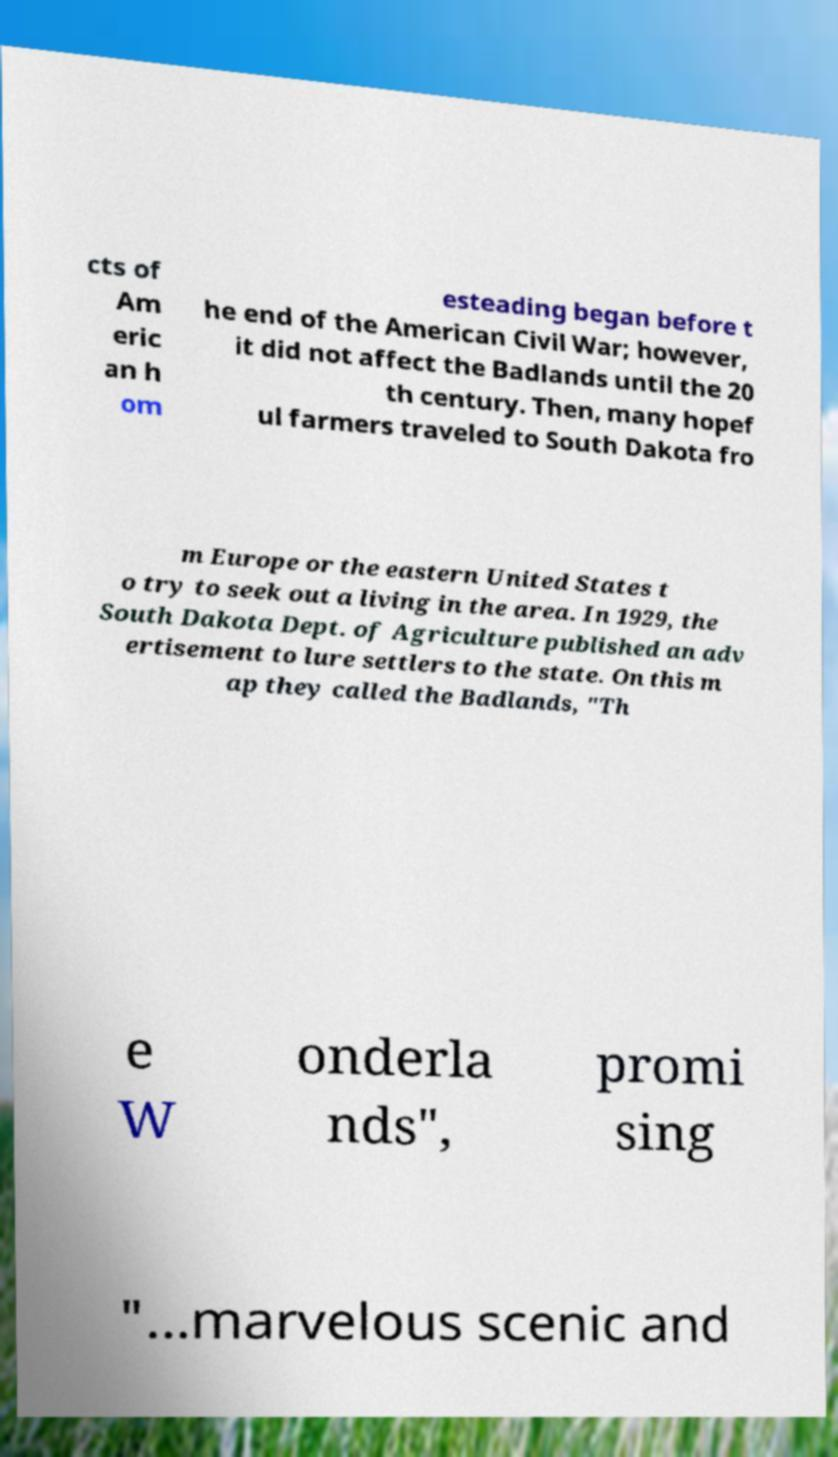Can you accurately transcribe the text from the provided image for me? cts of Am eric an h om esteading began before t he end of the American Civil War; however, it did not affect the Badlands until the 20 th century. Then, many hopef ul farmers traveled to South Dakota fro m Europe or the eastern United States t o try to seek out a living in the area. In 1929, the South Dakota Dept. of Agriculture published an adv ertisement to lure settlers to the state. On this m ap they called the Badlands, "Th e W onderla nds", promi sing "...marvelous scenic and 